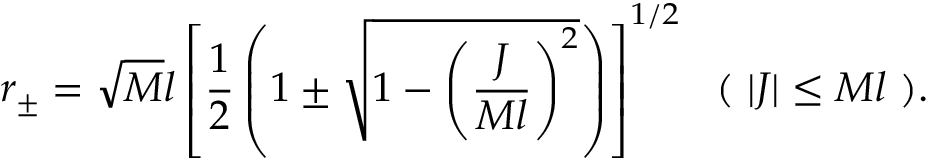Convert formula to latex. <formula><loc_0><loc_0><loc_500><loc_500>r _ { \pm } = \sqrt { M } l \left [ \frac { 1 } { 2 } \left ( 1 \pm \sqrt { 1 - \left ( \frac { J } { M l } \right ) ^ { 2 } } \right ) \right ] ^ { 1 / 2 } ( | J | \leq M l ) .</formula> 